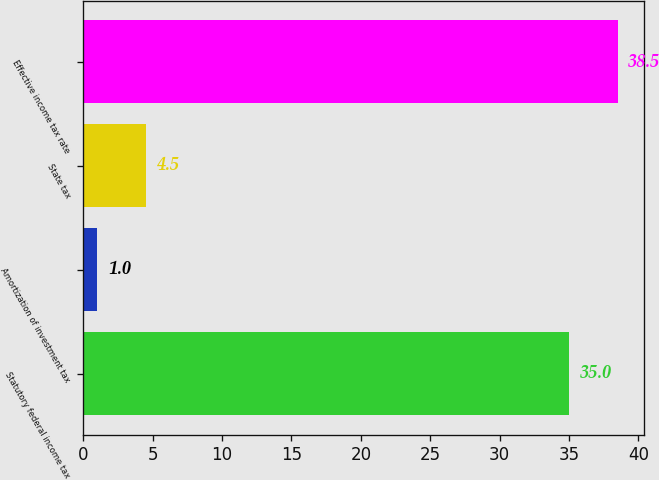<chart> <loc_0><loc_0><loc_500><loc_500><bar_chart><fcel>Statutory federal income tax<fcel>Amortization of investment tax<fcel>State tax<fcel>Effective income tax rate<nl><fcel>35<fcel>1<fcel>4.5<fcel>38.5<nl></chart> 